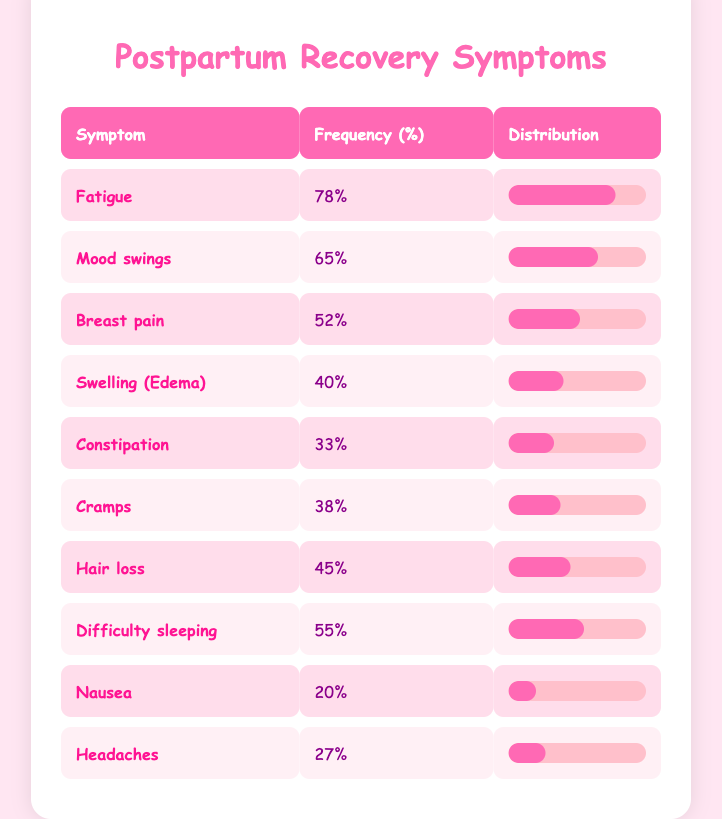What symptom has the highest frequency of occurrence among new mothers? According to the table, "Fatigue" has a frequency of 78%, which is higher than any other symptom.
Answer: Fatigue How many new mothers experienced mood swings? The frequency of "Mood swings" in the table is 65, indicating that this many mothers experienced this symptom.
Answer: 65 What is the difference in frequency between breast pain and headaches? The frequency for "Breast pain" is 52 and for "Headaches" it is 27. To find the difference, subtract 27 from 52, which gives 25.
Answer: 25 Is it true that more mothers experienced difficulty sleeping than those who experienced cramps? "Difficulty sleeping" has a frequency of 55 while "Cramps" has a frequency of 38. Since 55 is greater than 38, the statement is true.
Answer: Yes What percentage of new mothers experienced nausea compared to hair loss? "Nausea" has a frequency of 20% and "Hair loss" has a frequency of 45%. To compare, hair loss is 25% higher than nausea.
Answer: 25% higher What is the average frequency of the symptoms listed in the table? To calculate the average frequency, sum all the frequencies: 78 + 65 + 52 + 40 + 33 + 38 + 45 + 55 + 20 + 27 = 459. There are 10 symptoms, so the average is 459/10 = 45.9%.
Answer: 45.9% How many symptoms have a frequency of 40% or higher? The symptoms with 40% or higher are Fatigue, Mood swings, Breast pain, Swelling (Edema), Difficulty sleeping, Cramps, Hair loss, which totals to 7 symptoms.
Answer: 7 Which symptom has the lowest frequency and what is that percentage? The lowest frequency is for "Nausea" with a frequency of 20%.
Answer: 20% 